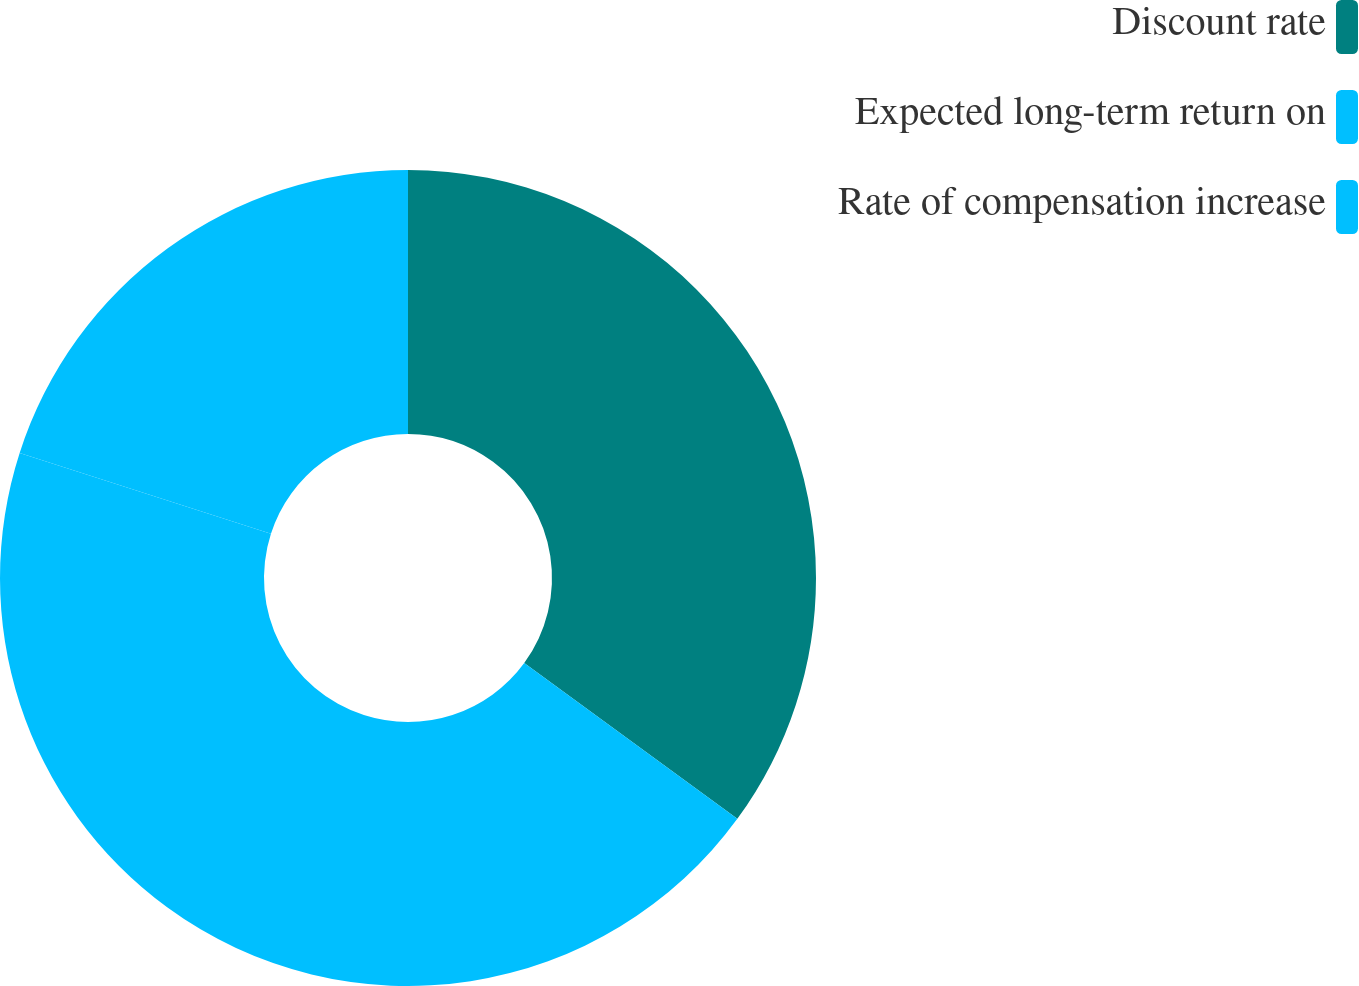<chart> <loc_0><loc_0><loc_500><loc_500><pie_chart><fcel>Discount rate<fcel>Expected long-term return on<fcel>Rate of compensation increase<nl><fcel>35.05%<fcel>44.91%<fcel>20.04%<nl></chart> 